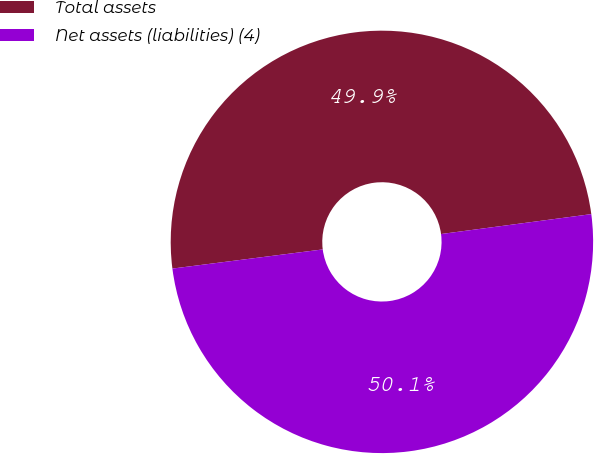Convert chart. <chart><loc_0><loc_0><loc_500><loc_500><pie_chart><fcel>Total assets<fcel>Net assets (liabilities) (4)<nl><fcel>49.92%<fcel>50.08%<nl></chart> 